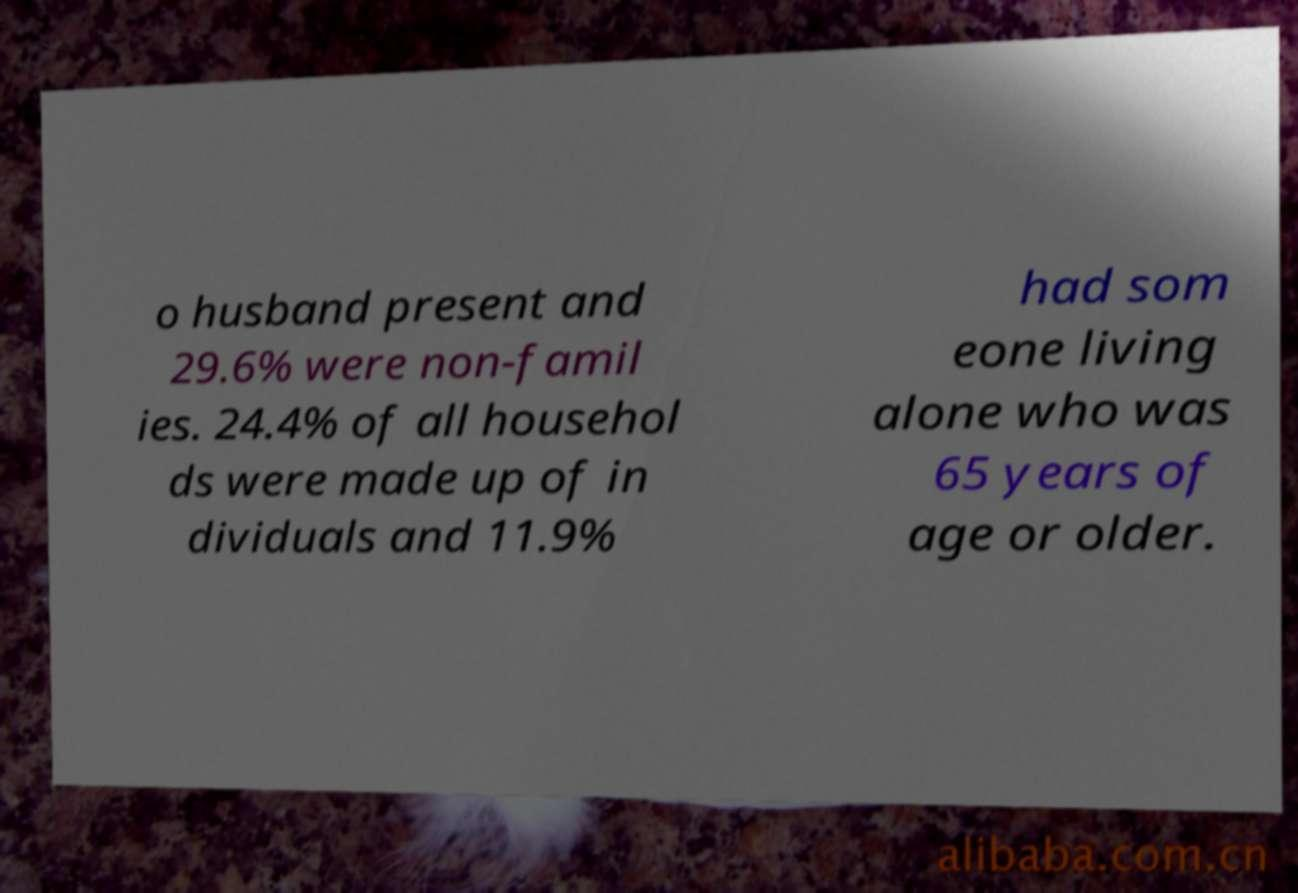Can you read and provide the text displayed in the image?This photo seems to have some interesting text. Can you extract and type it out for me? o husband present and 29.6% were non-famil ies. 24.4% of all househol ds were made up of in dividuals and 11.9% had som eone living alone who was 65 years of age or older. 